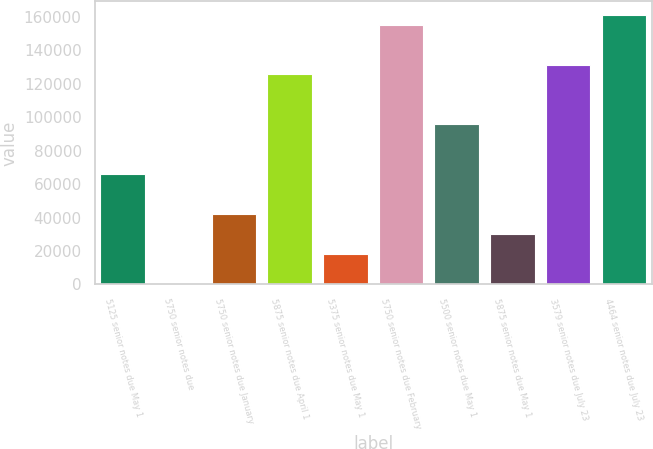Convert chart. <chart><loc_0><loc_0><loc_500><loc_500><bar_chart><fcel>5125 senior notes due May 1<fcel>5750 senior notes due<fcel>5750 senior notes due January<fcel>5875 senior notes due April 1<fcel>5375 senior notes due May 1<fcel>5750 senior notes due February<fcel>5500 senior notes due May 1<fcel>5875 senior notes due May 1<fcel>3579 senior notes due July 23<fcel>4464 senior notes due July 23<nl><fcel>65989.6<fcel>500<fcel>42175.2<fcel>125526<fcel>18360.8<fcel>155294<fcel>95757.6<fcel>30268<fcel>131479<fcel>161247<nl></chart> 